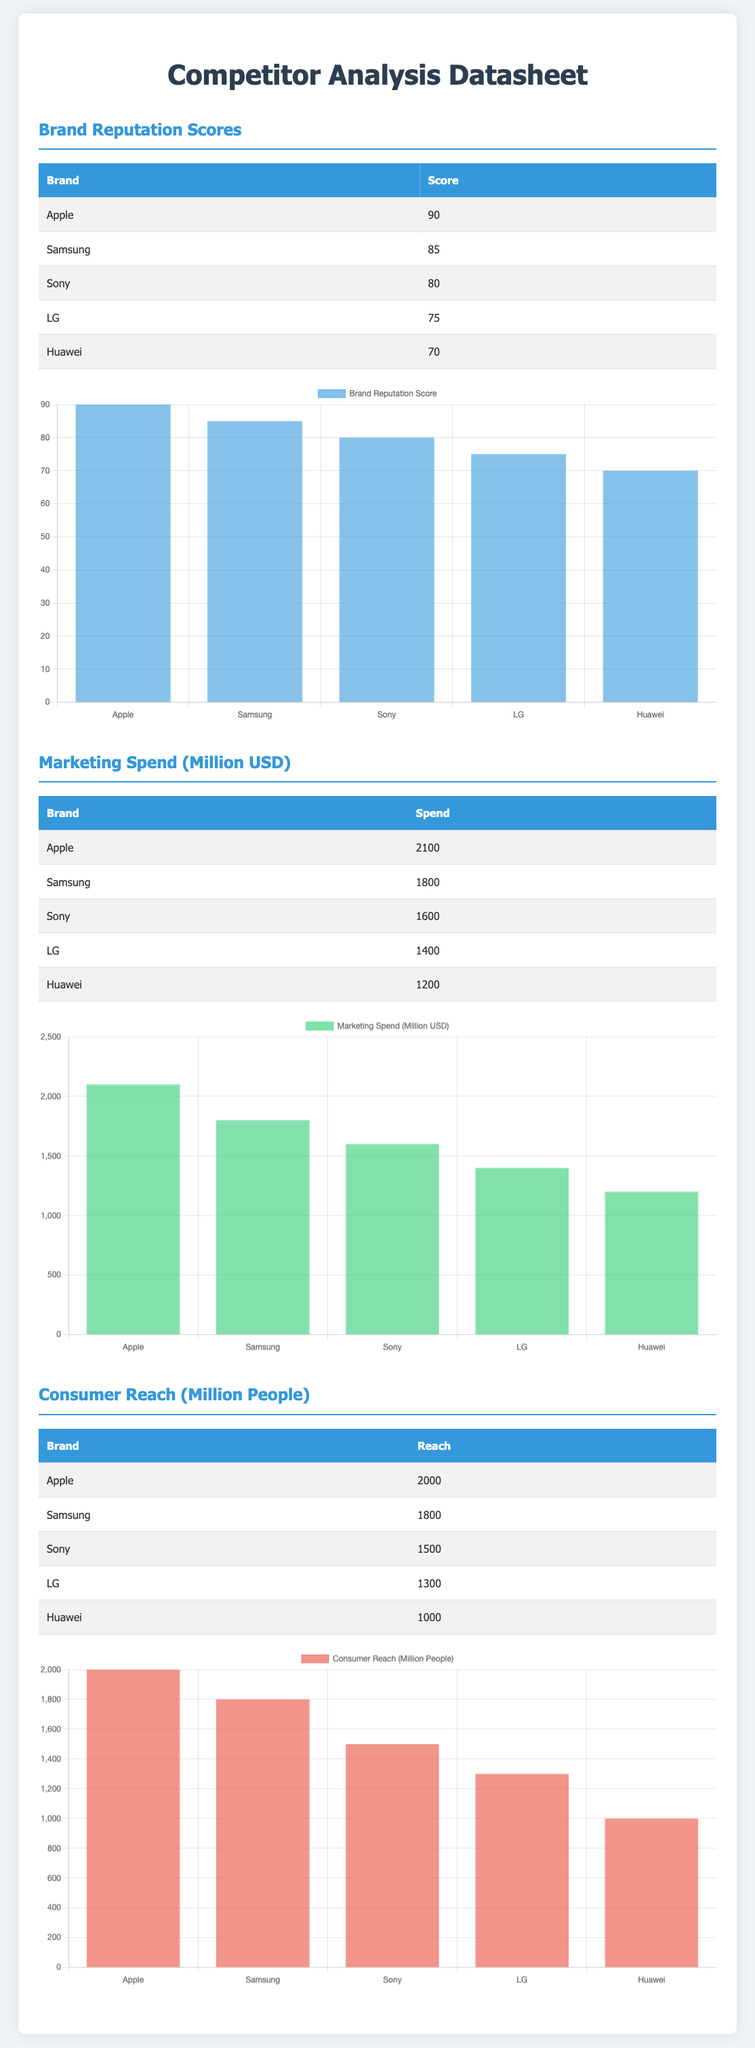What is Apple’s brand reputation score? The document lists Apple's brand reputation score as 90.
Answer: 90 What is the marketing spend of Sony in million USD? According to the document, Sony's marketing spend is 1600 million USD.
Answer: 1600 What is the consumer reach of Huawei in million people? Huawei’s consumer reach is provided as 1000 million people in the document.
Answer: 1000 Which brand has the highest marketing spend? The document shows that Apple has the highest marketing spend at 2100 million USD.
Answer: Apple What trend can be observed regarding brand reputation and marketing spend? The document indicates a trend that higher marketing spend is associated with higher brand reputation scores among the listed brands.
Answer: Higher marketing spend correlates with higher reputation What is the average consumer reach for the brands listed? The average consumer reach can be calculated by adding all reaches and dividing by the number of brands: (2000 + 1800 + 1500 + 1300 + 1000) / 5 = 1320 million.
Answer: 1320 million How many brands have a score above 80? The document shows that three brands have a score above 80 (Apple, Samsung, Sony).
Answer: Three Which brand has the lowest marketing spend? According to the table presented, Huawei has the lowest marketing spend at 1200 million USD.
Answer: Huawei What type of data is presented in this document? This document presents comparative data for various brands focusing on reputation scores, marketing spend, and consumer reach.
Answer: Comparative data 